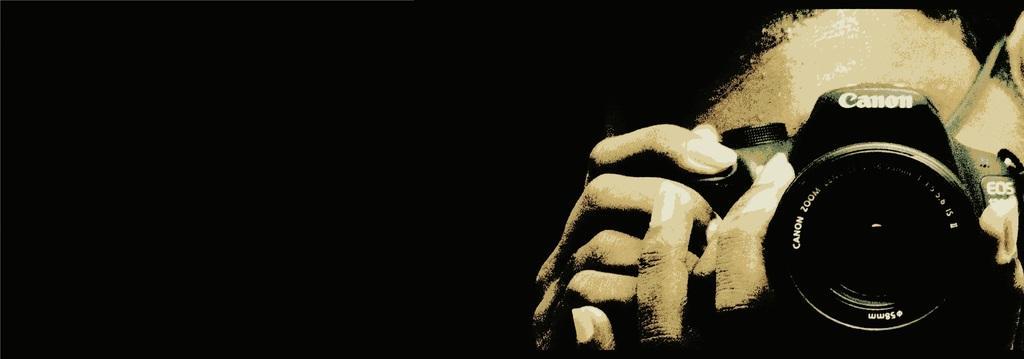Could you give a brief overview of what you see in this image? It is an edited image. In this image we can see some person holding the canon camera and the background is in black color. 